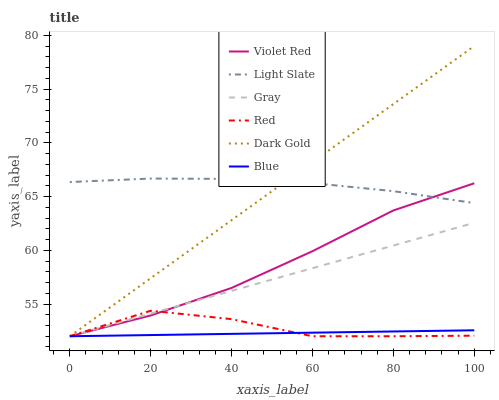Does Blue have the minimum area under the curve?
Answer yes or no. Yes. Does Light Slate have the maximum area under the curve?
Answer yes or no. Yes. Does Gray have the minimum area under the curve?
Answer yes or no. No. Does Gray have the maximum area under the curve?
Answer yes or no. No. Is Gray the smoothest?
Answer yes or no. Yes. Is Red the roughest?
Answer yes or no. Yes. Is Violet Red the smoothest?
Answer yes or no. No. Is Violet Red the roughest?
Answer yes or no. No. Does Blue have the lowest value?
Answer yes or no. Yes. Does Light Slate have the lowest value?
Answer yes or no. No. Does Dark Gold have the highest value?
Answer yes or no. Yes. Does Gray have the highest value?
Answer yes or no. No. Is Red less than Light Slate?
Answer yes or no. Yes. Is Light Slate greater than Red?
Answer yes or no. Yes. Does Gray intersect Dark Gold?
Answer yes or no. Yes. Is Gray less than Dark Gold?
Answer yes or no. No. Is Gray greater than Dark Gold?
Answer yes or no. No. Does Red intersect Light Slate?
Answer yes or no. No. 